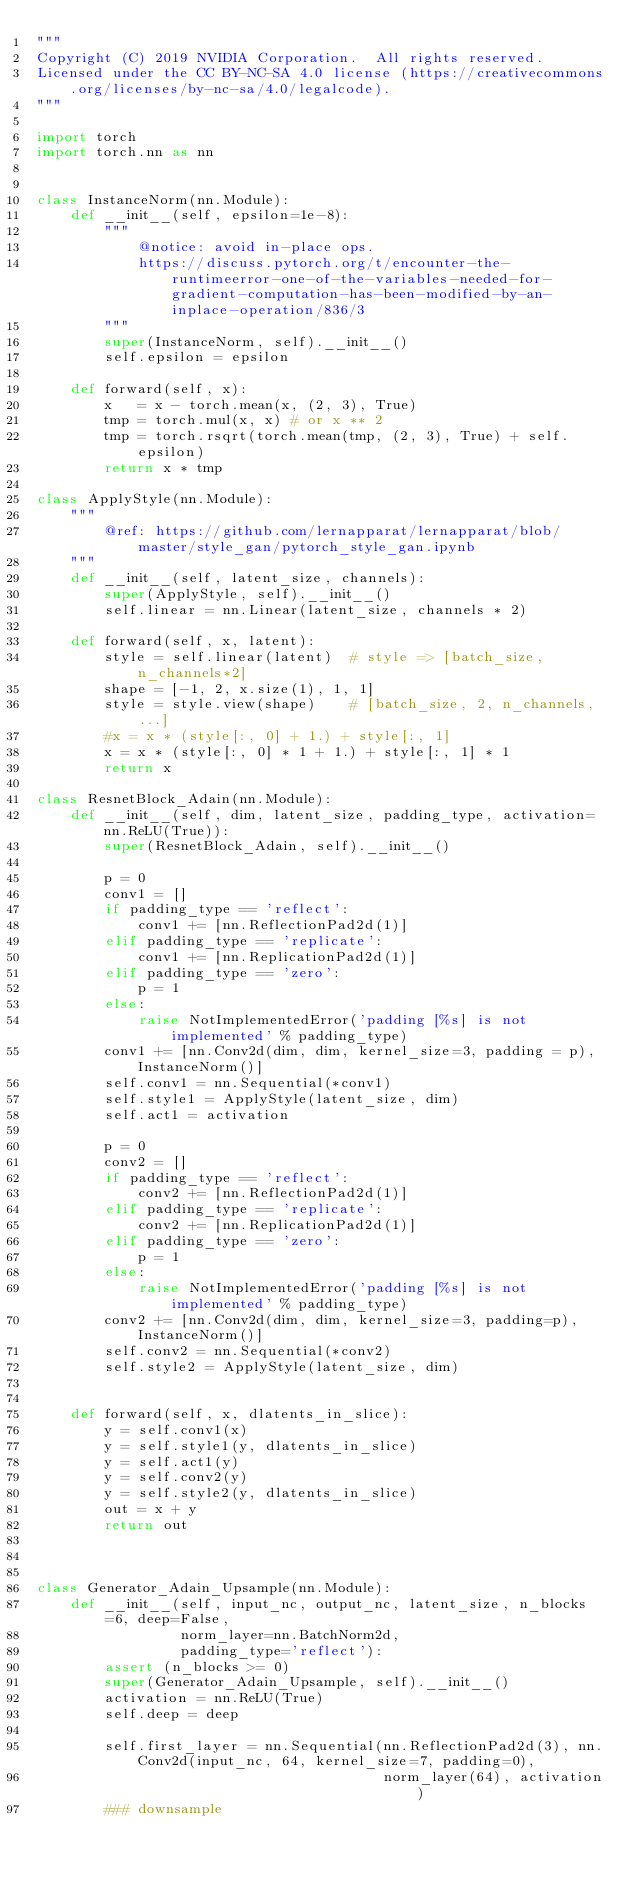Convert code to text. <code><loc_0><loc_0><loc_500><loc_500><_Python_>"""
Copyright (C) 2019 NVIDIA Corporation.  All rights reserved.
Licensed under the CC BY-NC-SA 4.0 license (https://creativecommons.org/licenses/by-nc-sa/4.0/legalcode).
"""

import torch
import torch.nn as nn


class InstanceNorm(nn.Module):
    def __init__(self, epsilon=1e-8):
        """
            @notice: avoid in-place ops.
            https://discuss.pytorch.org/t/encounter-the-runtimeerror-one-of-the-variables-needed-for-gradient-computation-has-been-modified-by-an-inplace-operation/836/3
        """
        super(InstanceNorm, self).__init__()
        self.epsilon = epsilon

    def forward(self, x):
        x   = x - torch.mean(x, (2, 3), True)
        tmp = torch.mul(x, x) # or x ** 2
        tmp = torch.rsqrt(torch.mean(tmp, (2, 3), True) + self.epsilon)
        return x * tmp

class ApplyStyle(nn.Module):
    """
        @ref: https://github.com/lernapparat/lernapparat/blob/master/style_gan/pytorch_style_gan.ipynb
    """
    def __init__(self, latent_size, channels):
        super(ApplyStyle, self).__init__()
        self.linear = nn.Linear(latent_size, channels * 2)

    def forward(self, x, latent):
        style = self.linear(latent)  # style => [batch_size, n_channels*2]
        shape = [-1, 2, x.size(1), 1, 1]
        style = style.view(shape)    # [batch_size, 2, n_channels, ...]
        #x = x * (style[:, 0] + 1.) + style[:, 1]
        x = x * (style[:, 0] * 1 + 1.) + style[:, 1] * 1
        return x

class ResnetBlock_Adain(nn.Module):
    def __init__(self, dim, latent_size, padding_type, activation=nn.ReLU(True)):
        super(ResnetBlock_Adain, self).__init__()

        p = 0
        conv1 = []
        if padding_type == 'reflect':
            conv1 += [nn.ReflectionPad2d(1)]
        elif padding_type == 'replicate':
            conv1 += [nn.ReplicationPad2d(1)]
        elif padding_type == 'zero':
            p = 1
        else:
            raise NotImplementedError('padding [%s] is not implemented' % padding_type)
        conv1 += [nn.Conv2d(dim, dim, kernel_size=3, padding = p), InstanceNorm()]
        self.conv1 = nn.Sequential(*conv1)
        self.style1 = ApplyStyle(latent_size, dim)
        self.act1 = activation

        p = 0
        conv2 = []
        if padding_type == 'reflect':
            conv2 += [nn.ReflectionPad2d(1)]
        elif padding_type == 'replicate':
            conv2 += [nn.ReplicationPad2d(1)]
        elif padding_type == 'zero':
            p = 1
        else:
            raise NotImplementedError('padding [%s] is not implemented' % padding_type)
        conv2 += [nn.Conv2d(dim, dim, kernel_size=3, padding=p), InstanceNorm()]
        self.conv2 = nn.Sequential(*conv2)
        self.style2 = ApplyStyle(latent_size, dim)


    def forward(self, x, dlatents_in_slice):
        y = self.conv1(x)
        y = self.style1(y, dlatents_in_slice)
        y = self.act1(y)
        y = self.conv2(y)
        y = self.style2(y, dlatents_in_slice)
        out = x + y
        return out



class Generator_Adain_Upsample(nn.Module):
    def __init__(self, input_nc, output_nc, latent_size, n_blocks=6, deep=False,
                 norm_layer=nn.BatchNorm2d,
                 padding_type='reflect'):
        assert (n_blocks >= 0)
        super(Generator_Adain_Upsample, self).__init__()
        activation = nn.ReLU(True)
        self.deep = deep

        self.first_layer = nn.Sequential(nn.ReflectionPad2d(3), nn.Conv2d(input_nc, 64, kernel_size=7, padding=0),
                                         norm_layer(64), activation)
        ### downsample</code> 